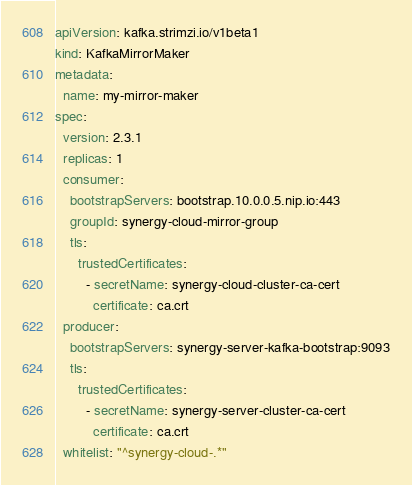<code> <loc_0><loc_0><loc_500><loc_500><_YAML_>apiVersion: kafka.strimzi.io/v1beta1
kind: KafkaMirrorMaker
metadata:
  name: my-mirror-maker
spec:
  version: 2.3.1
  replicas: 1
  consumer:
    bootstrapServers: bootstrap.10.0.0.5.nip.io:443
    groupId: synergy-cloud-mirror-group
    tls:
      trustedCertificates:
        - secretName: synergy-cloud-cluster-ca-cert
          certificate: ca.crt
  producer:
    bootstrapServers: synergy-server-kafka-bootstrap:9093
    tls:
      trustedCertificates:
        - secretName: synergy-server-cluster-ca-cert
          certificate: ca.crt
  whitelist: "^synergy-cloud-.*"
</code> 